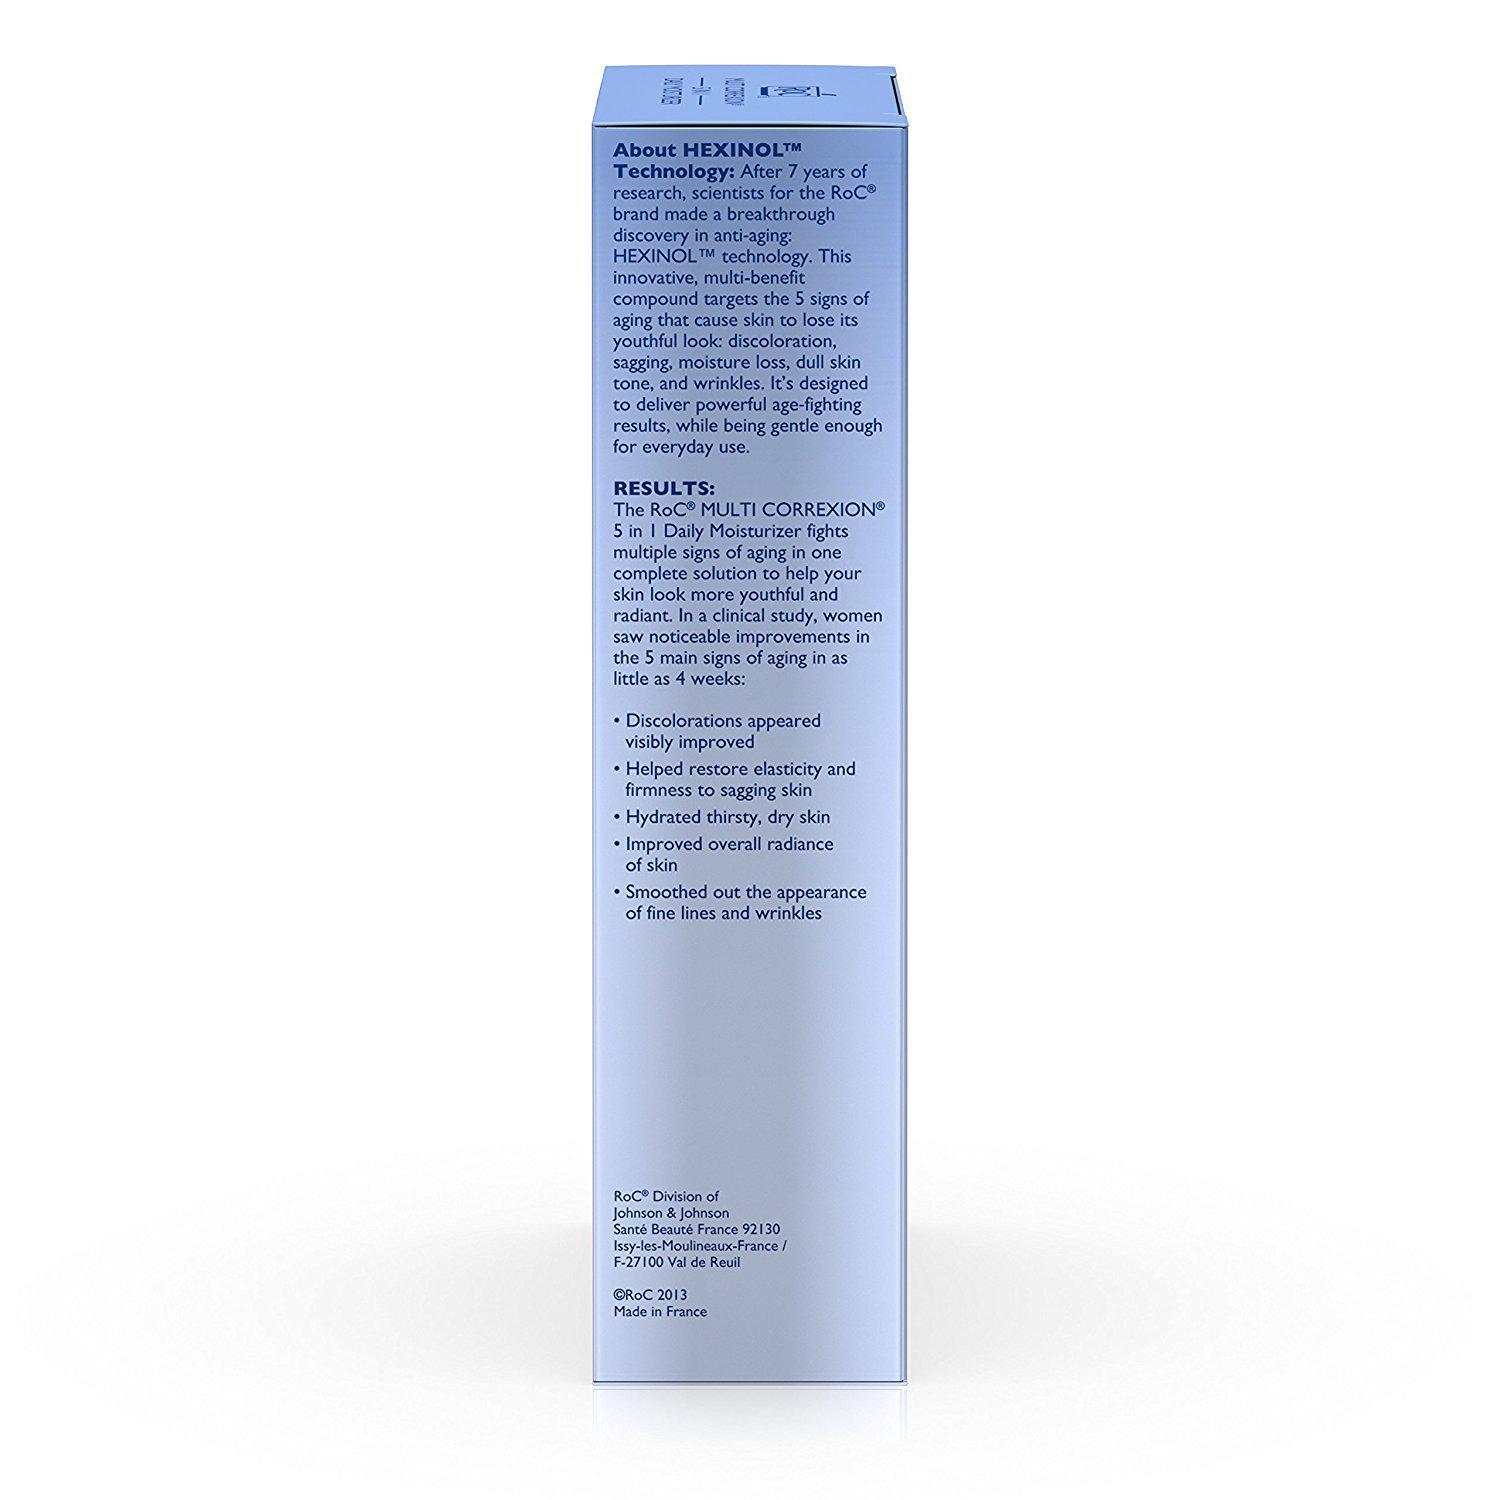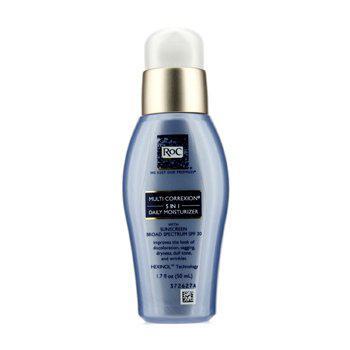The first image is the image on the left, the second image is the image on the right. Assess this claim about the two images: "Each image depicts one skincare product next to its box.". Correct or not? Answer yes or no. No. The first image is the image on the left, the second image is the image on the right. Assess this claim about the two images: "In each image, exactly one product is beside its box.". Correct or not? Answer yes or no. No. 